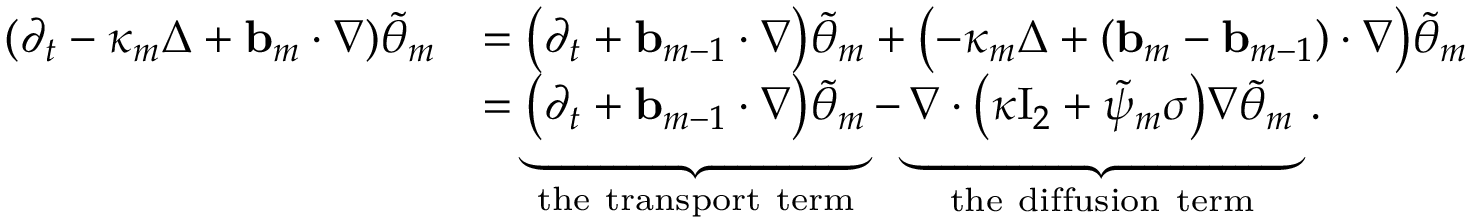<formula> <loc_0><loc_0><loc_500><loc_500>\begin{array} { r l } { ( \partial _ { t } - \kappa _ { m } \Delta + { b } _ { m } \cdot \nabla ) \tilde { \theta } _ { m } } & { = \left ( \partial _ { t } + { b } _ { m - 1 } \cdot \nabla \right ) \tilde { \theta } _ { m } + \left ( - \kappa _ { m } \Delta + ( { b } _ { m } - { b } _ { m - 1 } ) \cdot \nabla \right ) \tilde { \theta } _ { m } } \\ & { = \underbrace { \left ( \partial _ { t } + { b } _ { m - 1 } \cdot \nabla \right ) \tilde { \theta } _ { m } } _ { t h e t r a n s p o r t t e r m } - \underbrace { \nabla \cdot \left ( \kappa { I _ { 2 } } + \tilde { \psi } _ { m } \sigma \right ) \nabla \tilde { \theta } _ { m } } _ { t h e d i f f u s i o n t e r m } \, . } \end{array}</formula> 